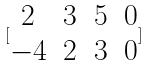Convert formula to latex. <formula><loc_0><loc_0><loc_500><loc_500>[ \begin{matrix} 2 & 3 & 5 & 0 \\ - 4 & 2 & 3 & 0 \end{matrix} ]</formula> 